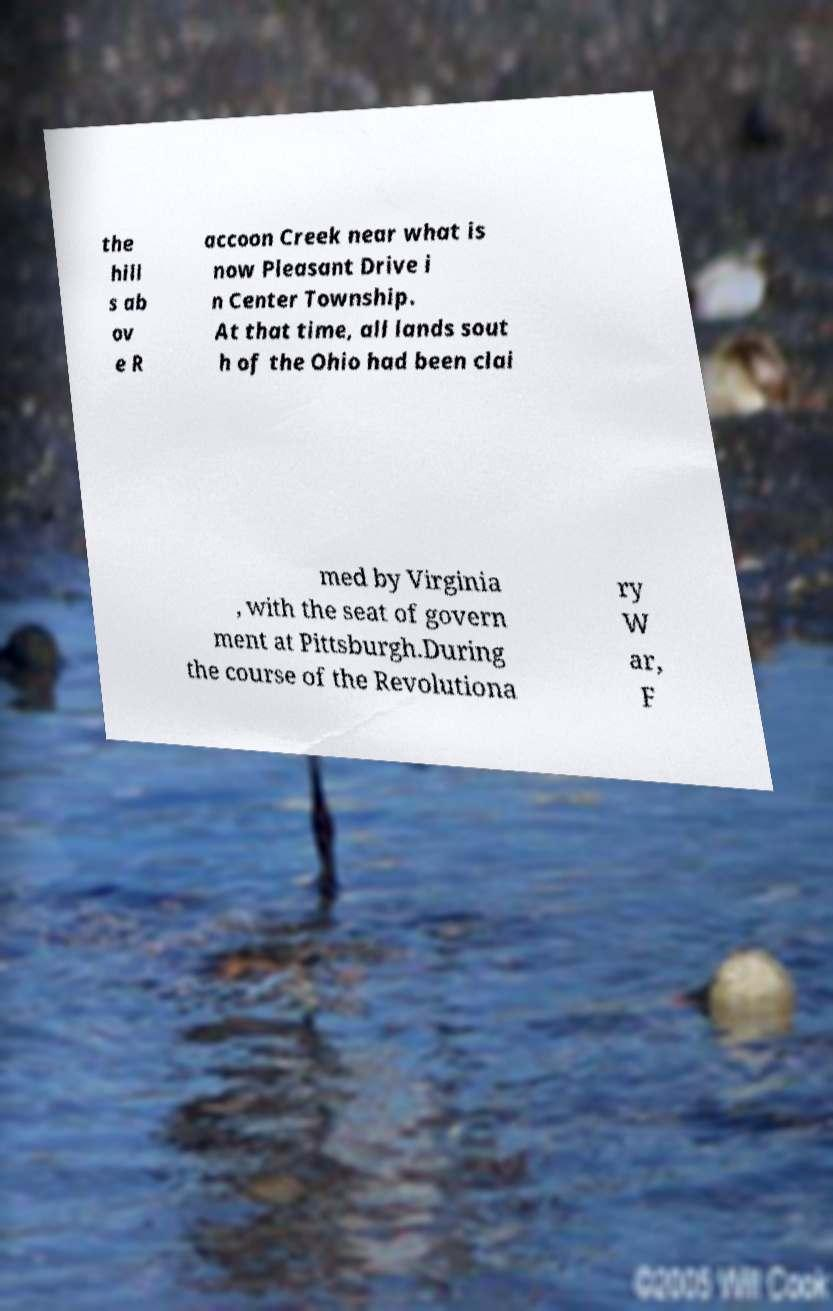I need the written content from this picture converted into text. Can you do that? the hill s ab ov e R accoon Creek near what is now Pleasant Drive i n Center Township. At that time, all lands sout h of the Ohio had been clai med by Virginia , with the seat of govern ment at Pittsburgh.During the course of the Revolutiona ry W ar, F 